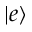<formula> <loc_0><loc_0><loc_500><loc_500>| e \rangle</formula> 